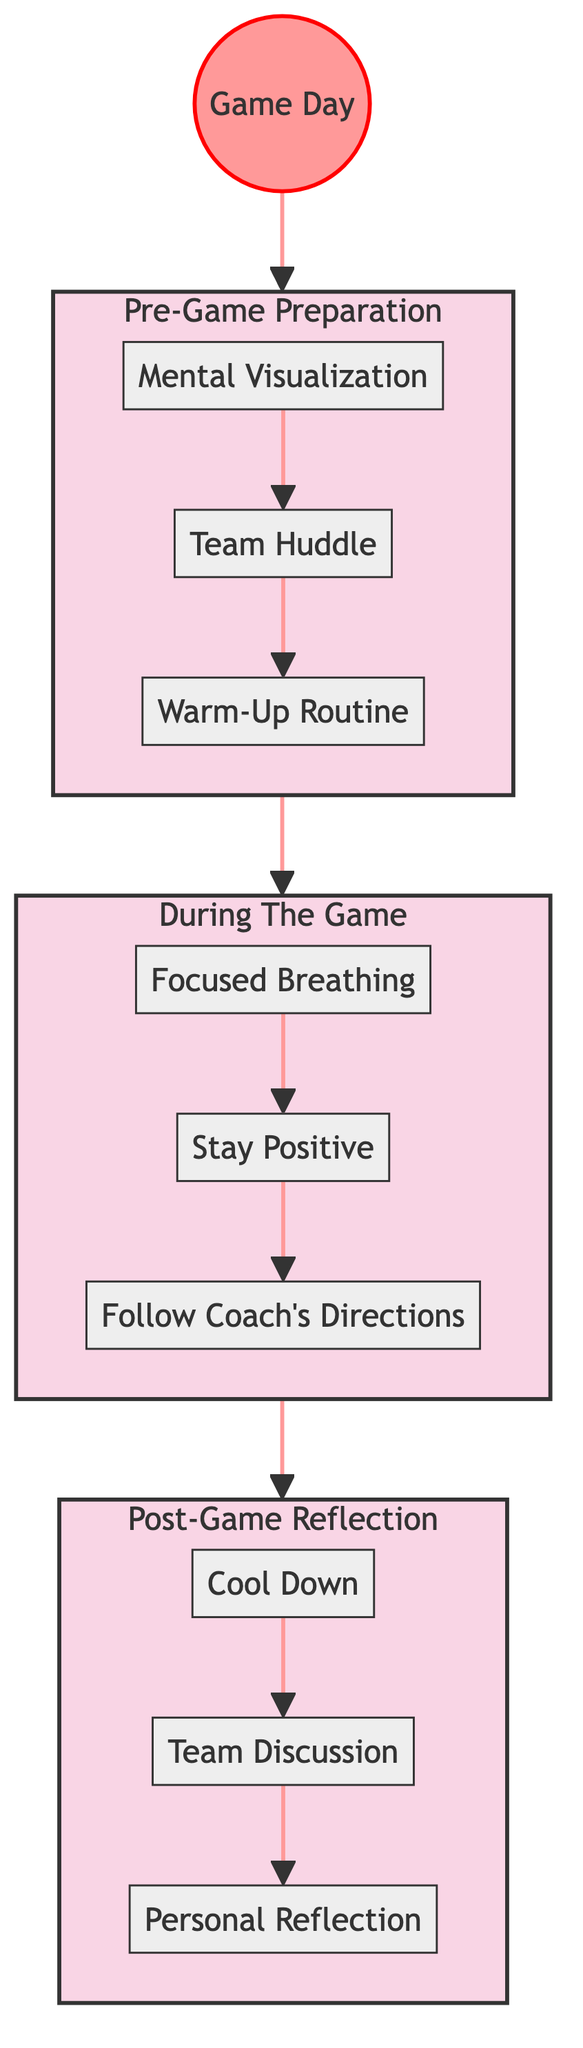What are the three steps in the Pre-Game Preparation stage? The steps listed in the Pre-Game Preparation stage are: Mental Visualization, Team Huddle, and Warm-Up Routine. These are clearly presented as part of that stage in the flowchart.
Answer: Mental Visualization, Team Huddle, Warm-Up Routine How many steps are there in the During The Game stage? The During The Game stage contains three steps: Focused Breathing, Stay Positive, and Follow Coach's Directions, which can be counted from the flowchart.
Answer: 3 What is the last step in the Post-Game Reflection stage? The last step in the Post-Game Reflection stage is Personal Reflection, which can be determined by looking at the order of steps in that stage.
Answer: Personal Reflection Which step follows the Team Huddle? According to the flowchart, the step that follows Team Huddle in the Pre-Game Preparation stage is Warm-Up Routine, which can be seen directly from the diagram flow.
Answer: Warm-Up Routine What is the relationship between the Pre-Game Preparation and During The Game stages? The Pre-Game Preparation stage clearly leads into the During The Game stage in the flowchart, indicating that the steps in the first stage are required before the steps in the next stage.
Answer: Leads into What are the three main stages of handling game-day pressure? The main stages of handling game-day pressure as shown in the diagram are Pre-Game Preparation, During The Game, and Post-Game Reflection, presented sequentially.
Answer: Pre-Game Preparation, During The Game, Post-Game Reflection How many main stages are depicted in the diagram? The diagram presents a total of three main stages: Pre-Game Preparation, During The Game, and Post-Game Reflection, which can be counted from the structure of the flowchart.
Answer: 3 Which step emphasizes maintaining a positive mindset during the game? The step that emphasizes maintaining a positive mindset during the game is Stay Positive, which is explicitly mentioned in the During The Game stage of the flowchart.
Answer: Stay Positive What activity is suggested to help you relax after the game? The activity suggested to help you relax after the game is Cool Down, as indicated in the Post-Game Reflection stage of the diagram.
Answer: Cool Down 